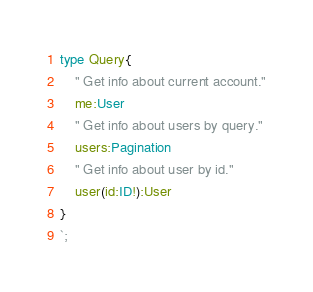Convert code to text. <code><loc_0><loc_0><loc_500><loc_500><_TypeScript_>
type Query{
    " Get info about current account."
    me:User
    " Get info about users by query."
    users:Pagination    
    " Get info about user by id."
    user(id:ID!):User    
}
`;</code> 